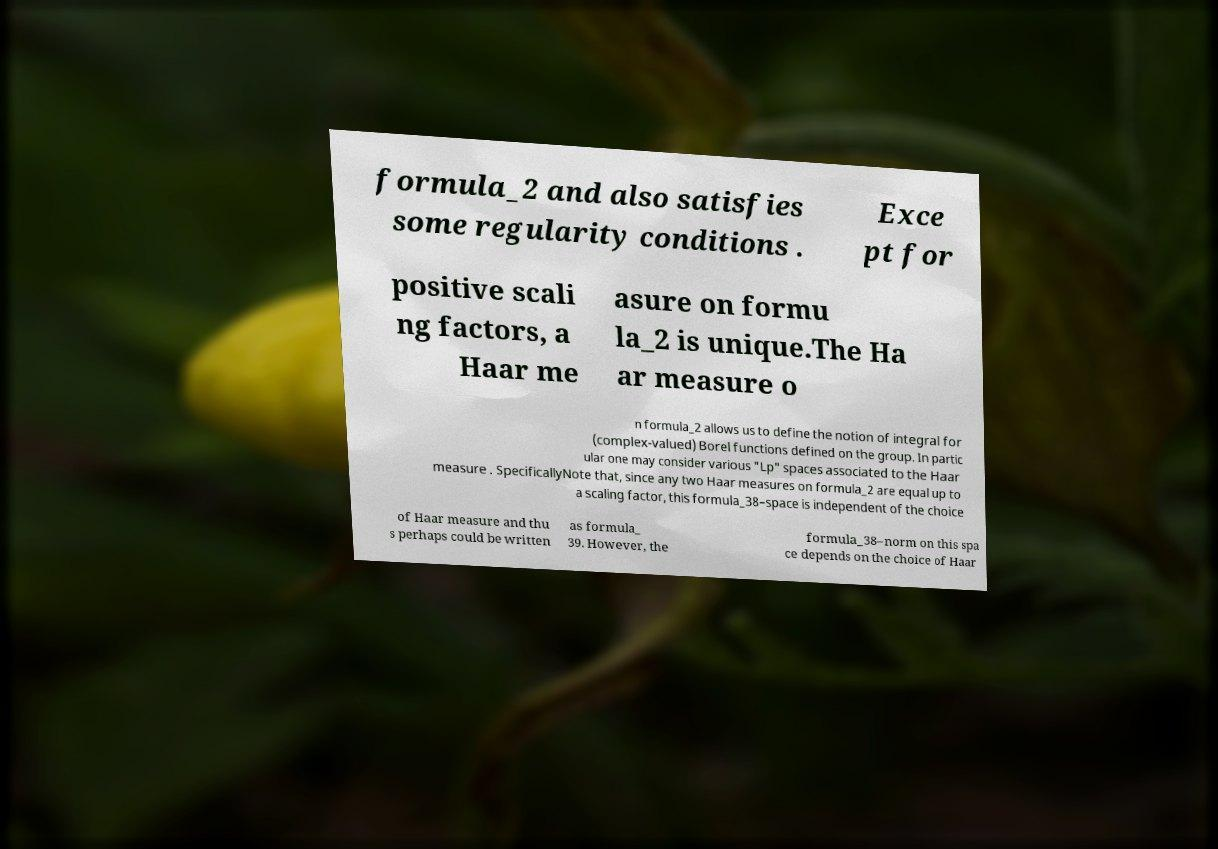For documentation purposes, I need the text within this image transcribed. Could you provide that? formula_2 and also satisfies some regularity conditions . Exce pt for positive scali ng factors, a Haar me asure on formu la_2 is unique.The Ha ar measure o n formula_2 allows us to define the notion of integral for (complex-valued) Borel functions defined on the group. In partic ular one may consider various "Lp" spaces associated to the Haar measure . SpecificallyNote that, since any two Haar measures on formula_2 are equal up to a scaling factor, this formula_38–space is independent of the choice of Haar measure and thu s perhaps could be written as formula_ 39. However, the formula_38–norm on this spa ce depends on the choice of Haar 